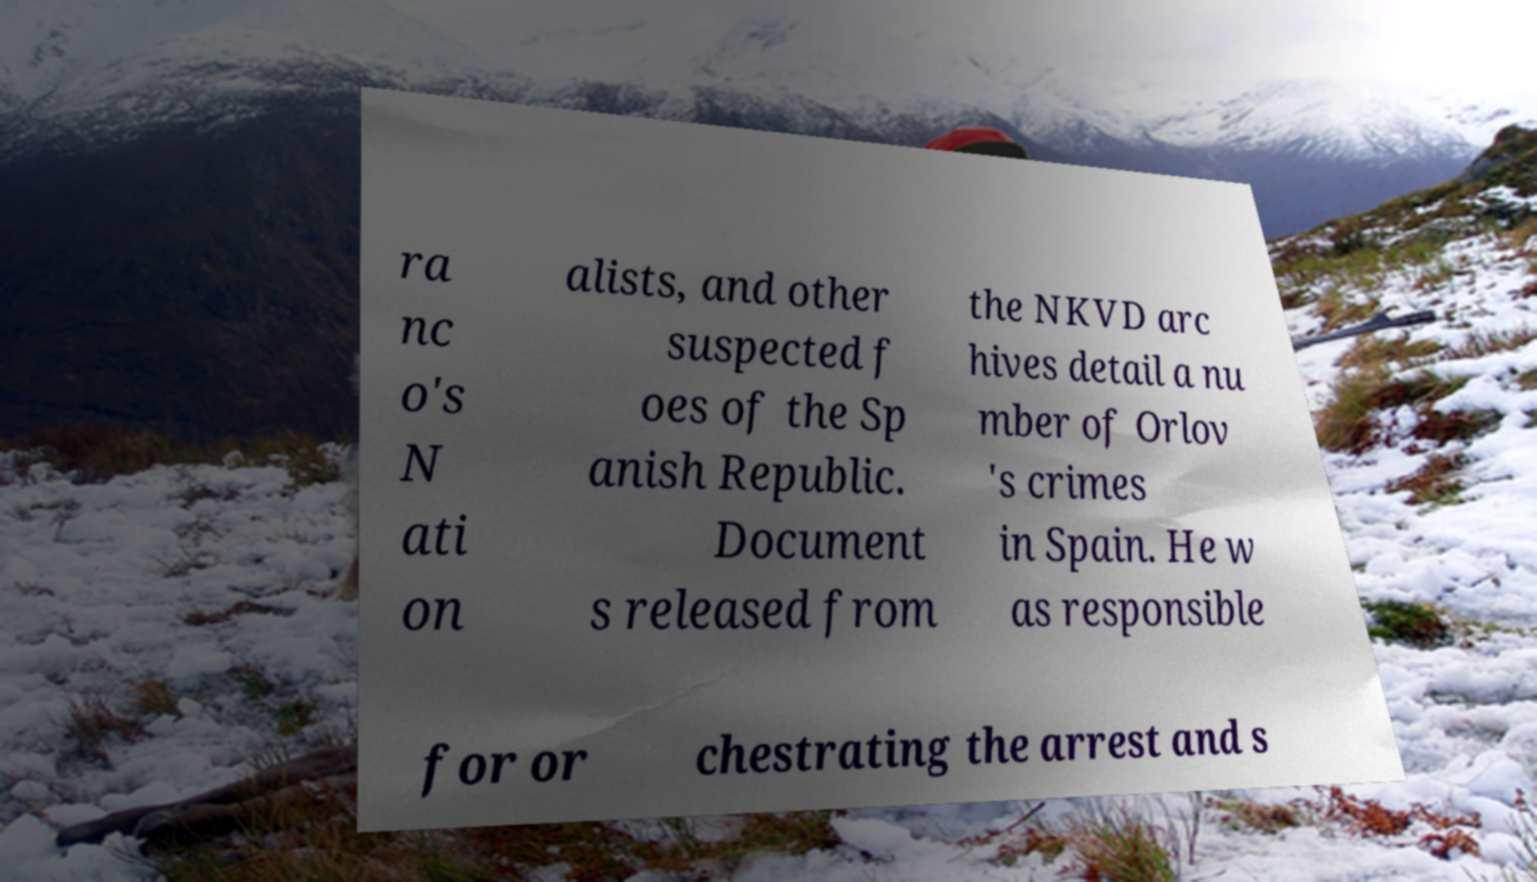For documentation purposes, I need the text within this image transcribed. Could you provide that? ra nc o's N ati on alists, and other suspected f oes of the Sp anish Republic. Document s released from the NKVD arc hives detail a nu mber of Orlov 's crimes in Spain. He w as responsible for or chestrating the arrest and s 